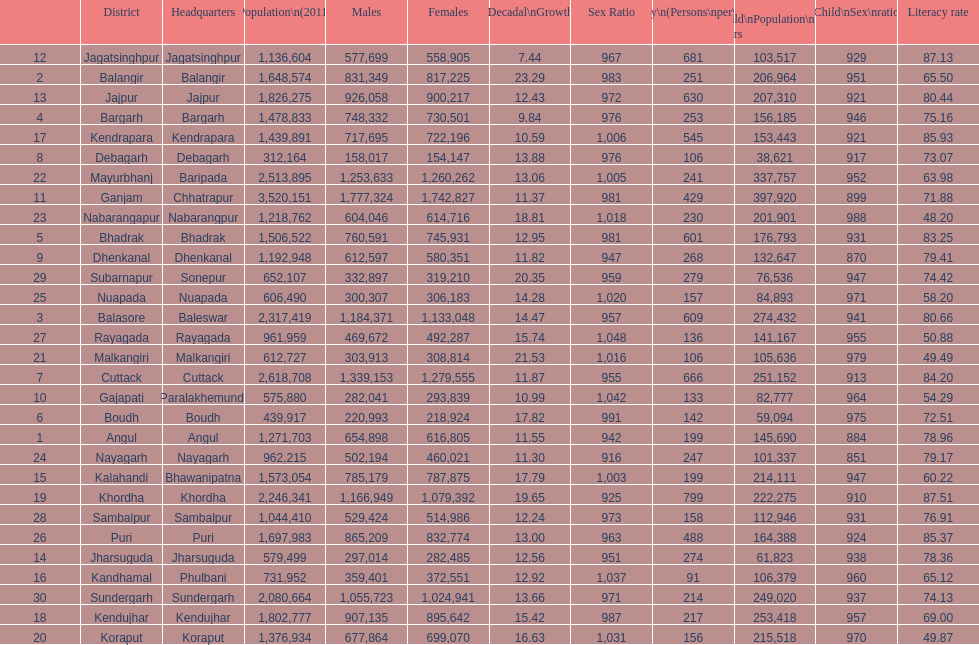What is the difference in child population between koraput and puri? 51,130. 